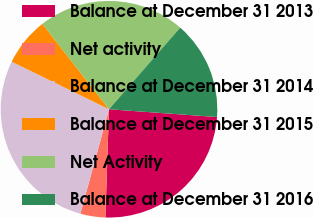Convert chart to OTSL. <chart><loc_0><loc_0><loc_500><loc_500><pie_chart><fcel>Balance at December 31 2013<fcel>Net activity<fcel>Balance at December 31 2014<fcel>Balance at December 31 2015<fcel>Net Activity<fcel>Balance at December 31 2016<nl><fcel>24.39%<fcel>3.73%<fcel>27.97%<fcel>7.23%<fcel>21.96%<fcel>14.73%<nl></chart> 